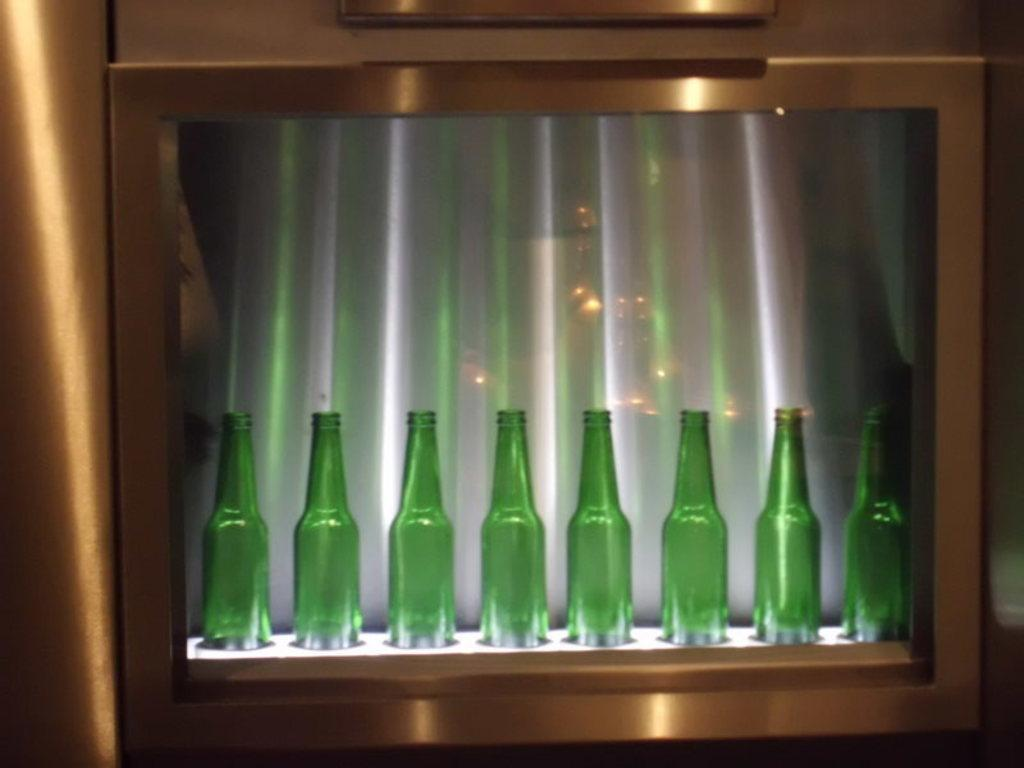What is the main subject of the image? The main subject of the image is a sequence of bottles. Where are the bottles located in the image? The bottles are inside a glass. What type of porter is present in the image? There is no porter present in the image; it features a sequence of bottles inside a glass. What activity is taking place during the recess in the image? There is no recess or any activity taking place in the image; it only shows a sequence of bottles inside a glass. 